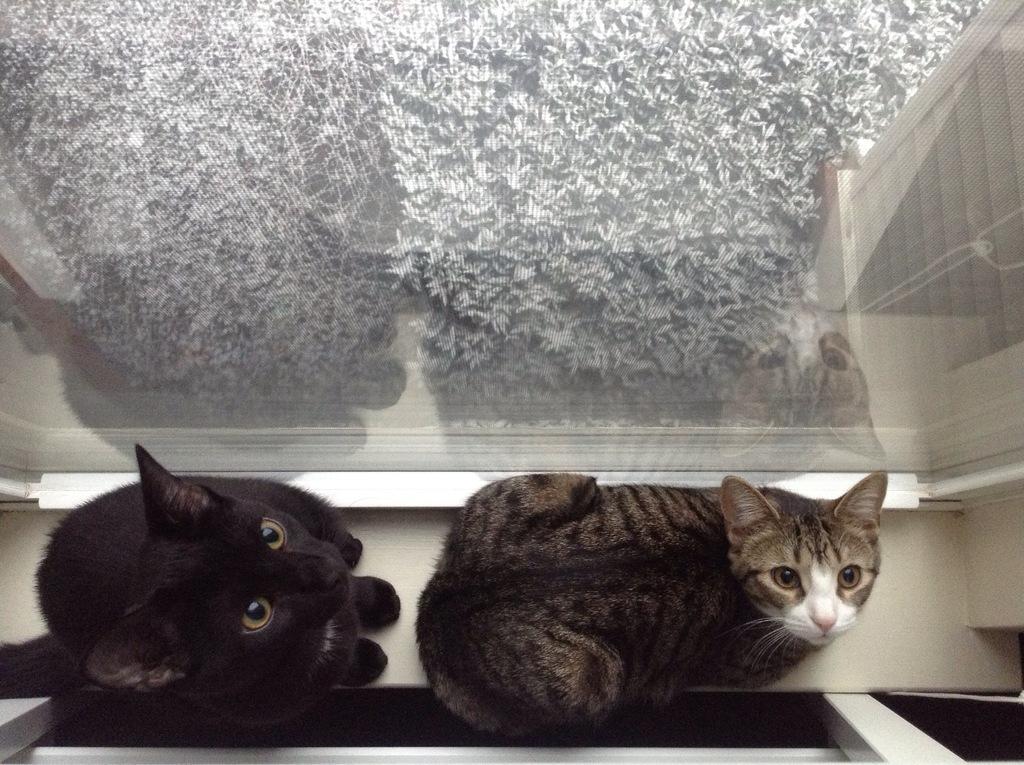Could you give a brief overview of what you see in this image? This picture is clicked inside. In the foreground we can see the two cats sitting on the floor. In the background we can see there are some objects. 